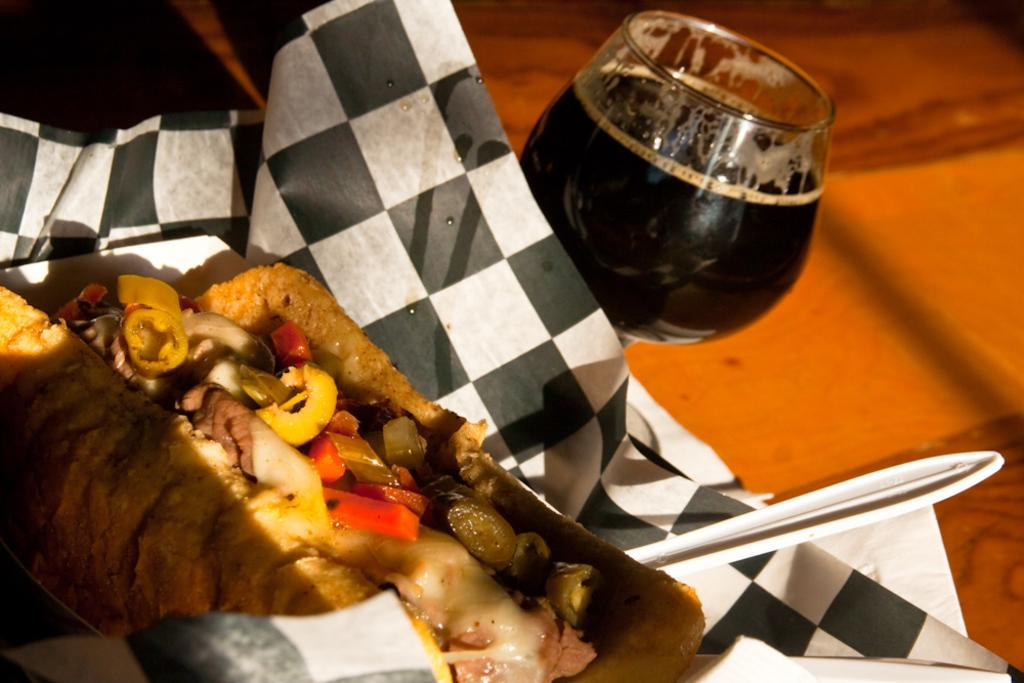What is: What is the main subject of the image? There is a food item in the image. How is the food item presented? The food item is wrapped. What else is included in the wrapper? There is a spoon in the wrapper. What can be seen next to the food item in the image? There is a glass of drink in the image. Where is the glass of drink located? The glass of drink is on a table. Who is the creator of the eggnog in the image? There is no eggnog present in the image, so it is not possible to determine the creator. 